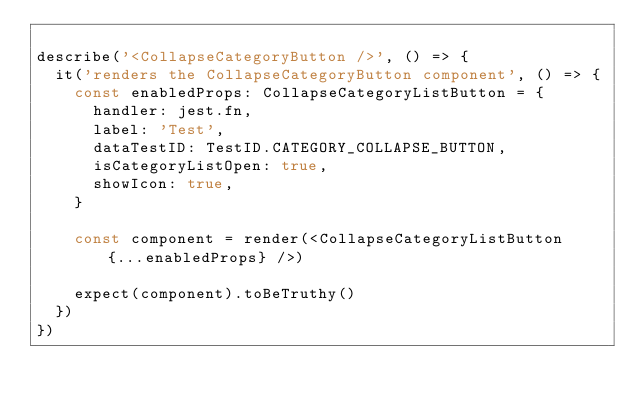Convert code to text. <code><loc_0><loc_0><loc_500><loc_500><_TypeScript_>
describe('<CollapseCategoryButton />', () => {
  it('renders the CollapseCategoryButton component', () => {
    const enabledProps: CollapseCategoryListButton = {
      handler: jest.fn,
      label: 'Test',
      dataTestID: TestID.CATEGORY_COLLAPSE_BUTTON,
      isCategoryListOpen: true,
      showIcon: true,
    }

    const component = render(<CollapseCategoryListButton {...enabledProps} />)

    expect(component).toBeTruthy()
  })
})
</code> 